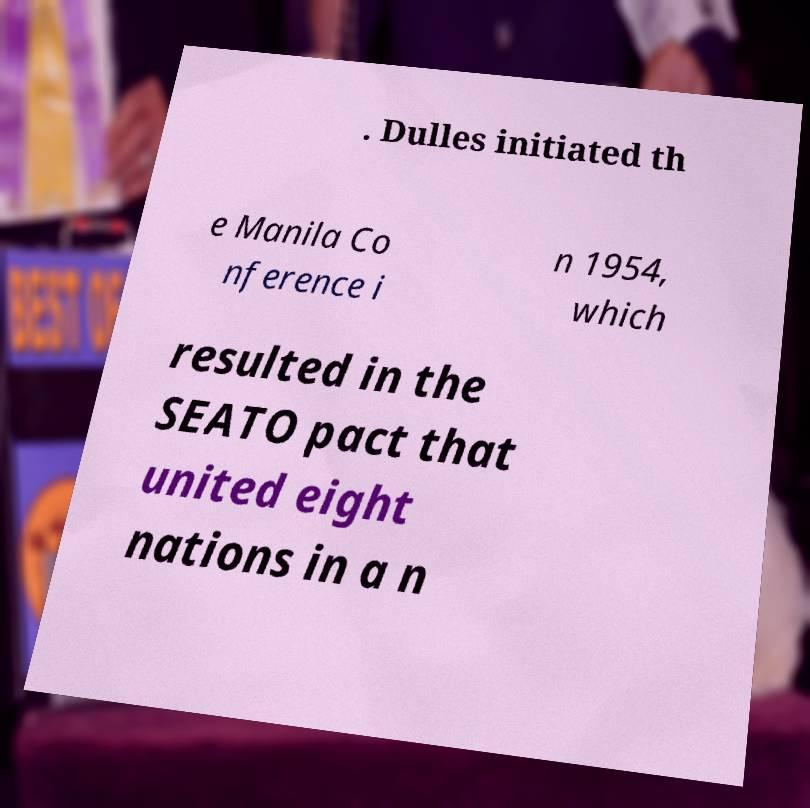Could you extract and type out the text from this image? . Dulles initiated th e Manila Co nference i n 1954, which resulted in the SEATO pact that united eight nations in a n 